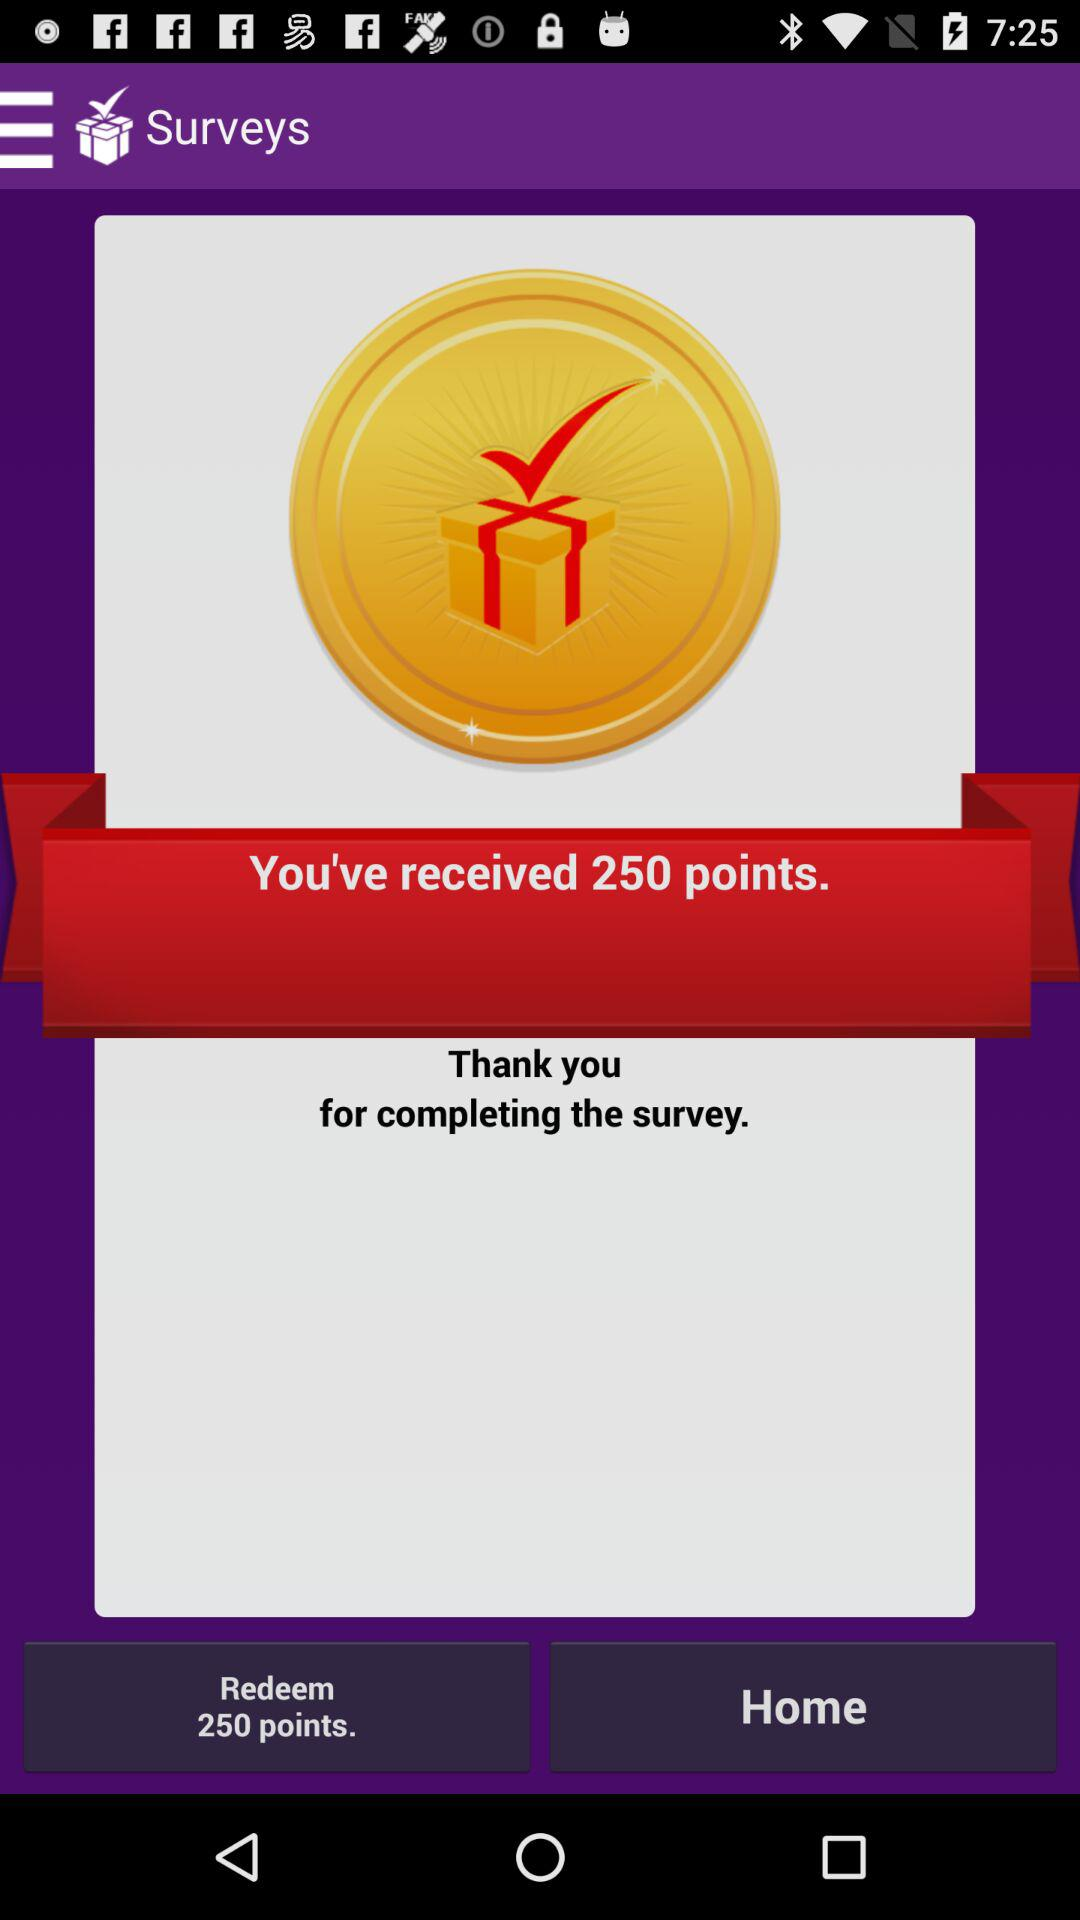How many points have I earned in total?
Answer the question using a single word or phrase. 250 